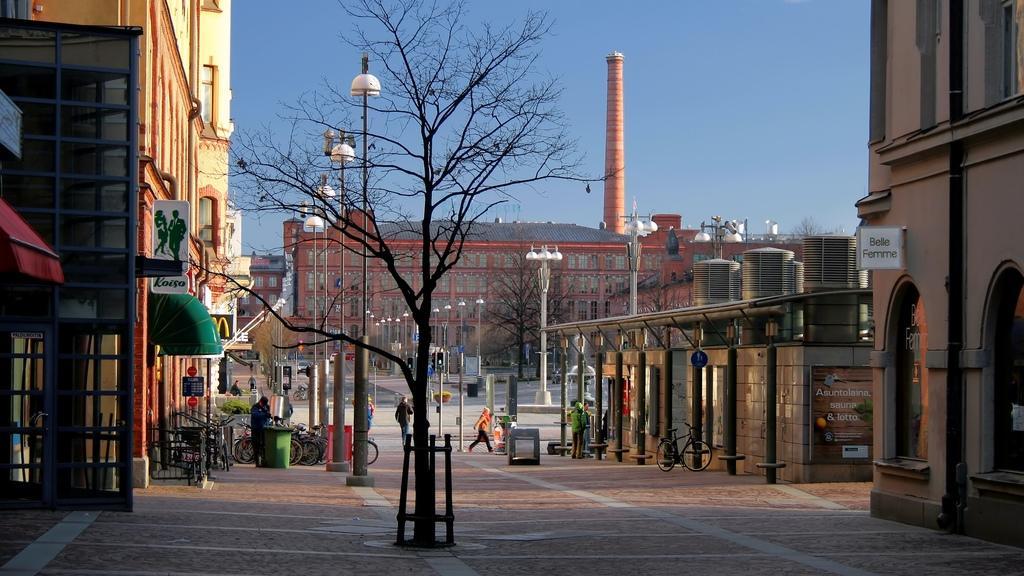In one or two sentences, can you explain what this image depicts? In the image we can see there are people standing on the ground and there are street light poles on the road. There are buildings and there are bicycles. 